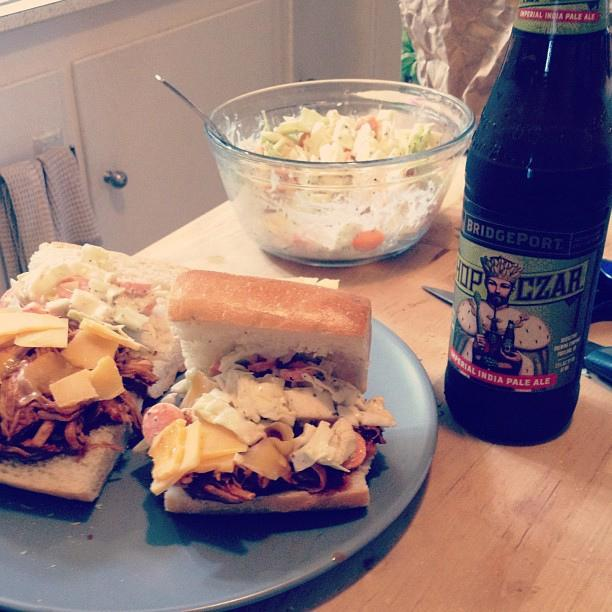Where was this food made?

Choices:
A) home
B) store
C) restaurant
D) outside home 